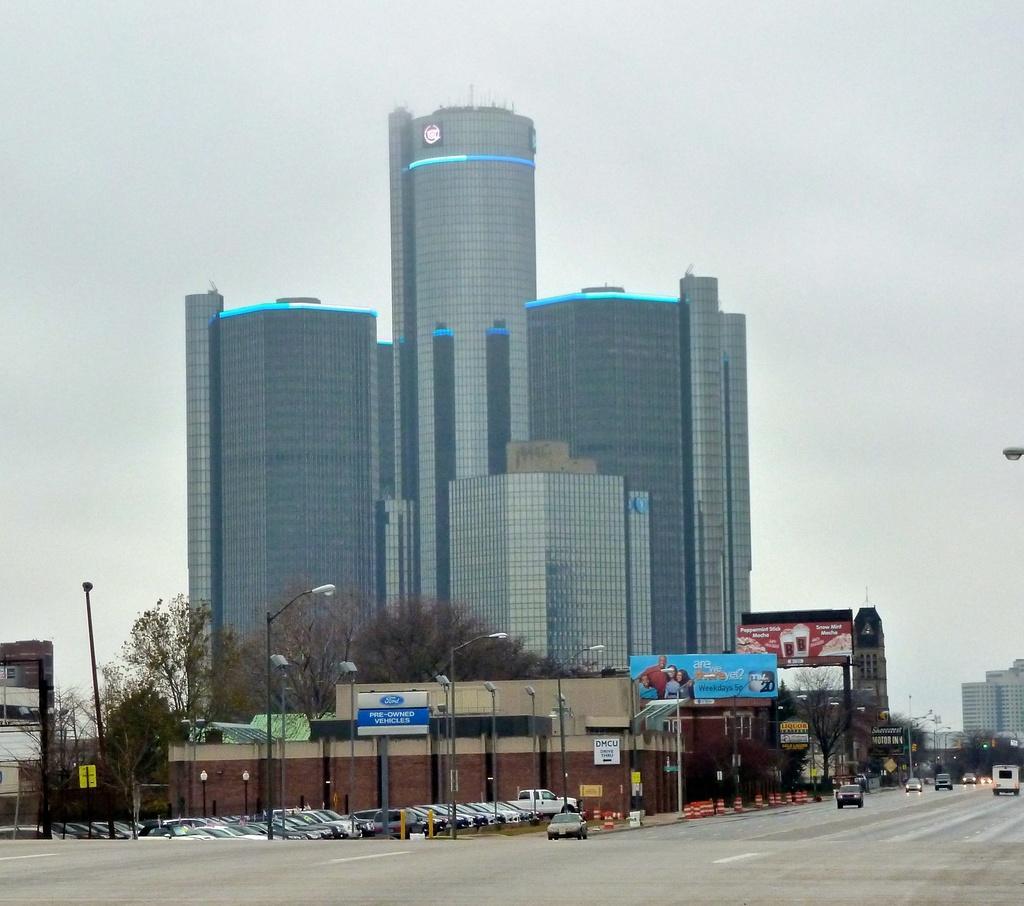Please provide a concise description of this image. This image is taken outdoors. At the top of the image there is the sky with clouds. At the bottom of the there is a road. On the right side of the image. There are a few buildings, trees and a few cars are moving on the road. In the middle of the image there are a few buildings. There is a skyscraper. There are a few trees. There are a few poles with street lights. There are a few boards with text on them. Many cars are parked on the ground and a few are moving on the road. 